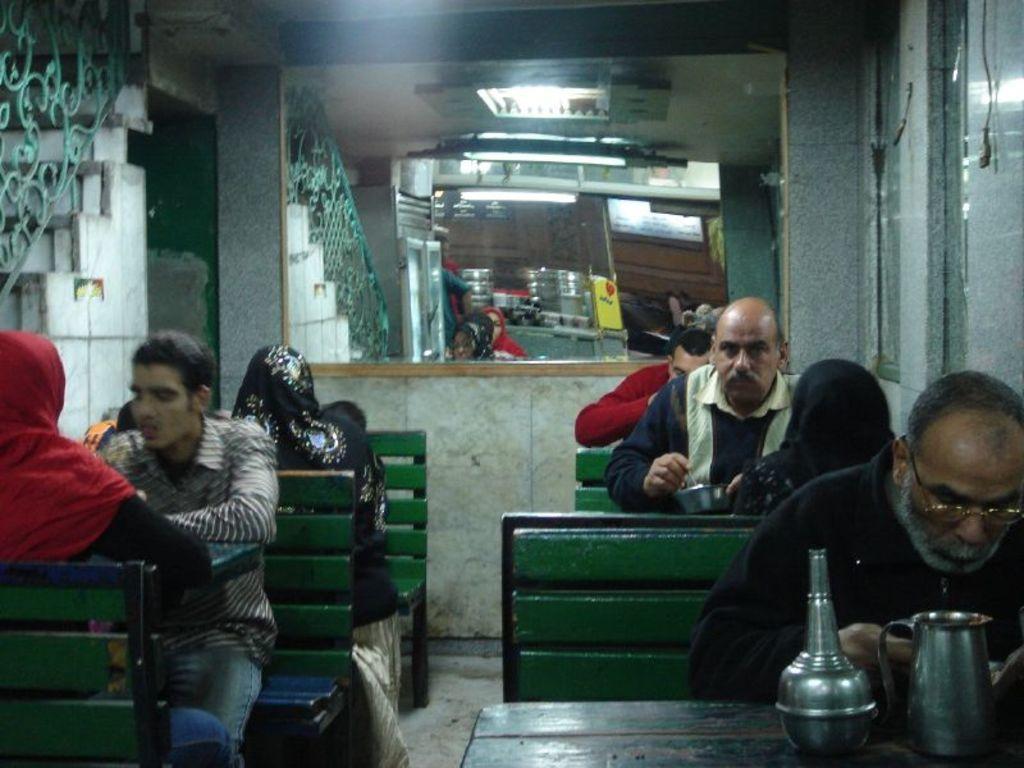Can you describe this image briefly? In this image, we can see some people sitting on the benches, there are some tables, we can see a jug on the table, there is a mirror. 